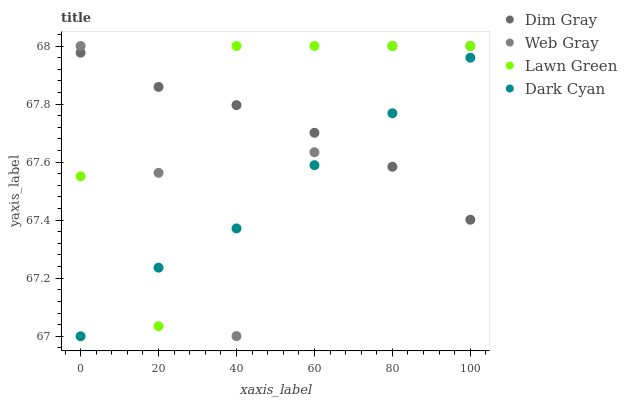Does Dark Cyan have the minimum area under the curve?
Answer yes or no. Yes. Does Lawn Green have the maximum area under the curve?
Answer yes or no. Yes. Does Dim Gray have the minimum area under the curve?
Answer yes or no. No. Does Dim Gray have the maximum area under the curve?
Answer yes or no. No. Is Dim Gray the smoothest?
Answer yes or no. Yes. Is Lawn Green the roughest?
Answer yes or no. Yes. Is Lawn Green the smoothest?
Answer yes or no. No. Is Dim Gray the roughest?
Answer yes or no. No. Does Dark Cyan have the lowest value?
Answer yes or no. Yes. Does Lawn Green have the lowest value?
Answer yes or no. No. Does Web Gray have the highest value?
Answer yes or no. Yes. Does Dim Gray have the highest value?
Answer yes or no. No. Does Lawn Green intersect Dim Gray?
Answer yes or no. Yes. Is Lawn Green less than Dim Gray?
Answer yes or no. No. Is Lawn Green greater than Dim Gray?
Answer yes or no. No. 